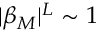Convert formula to latex. <formula><loc_0><loc_0><loc_500><loc_500>| \beta _ { M } | ^ { L } \sim 1</formula> 